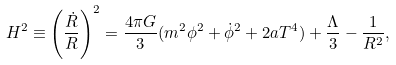<formula> <loc_0><loc_0><loc_500><loc_500>H ^ { 2 } \equiv \left ( \frac { \dot { R } } { R } \right ) ^ { 2 } = \frac { 4 \pi G } { 3 } ( m ^ { 2 } \phi ^ { 2 } + \dot { \phi } ^ { 2 } + 2 a T ^ { 4 } ) + \frac { \Lambda } { 3 } - \frac { 1 } { R ^ { 2 } } ,</formula> 